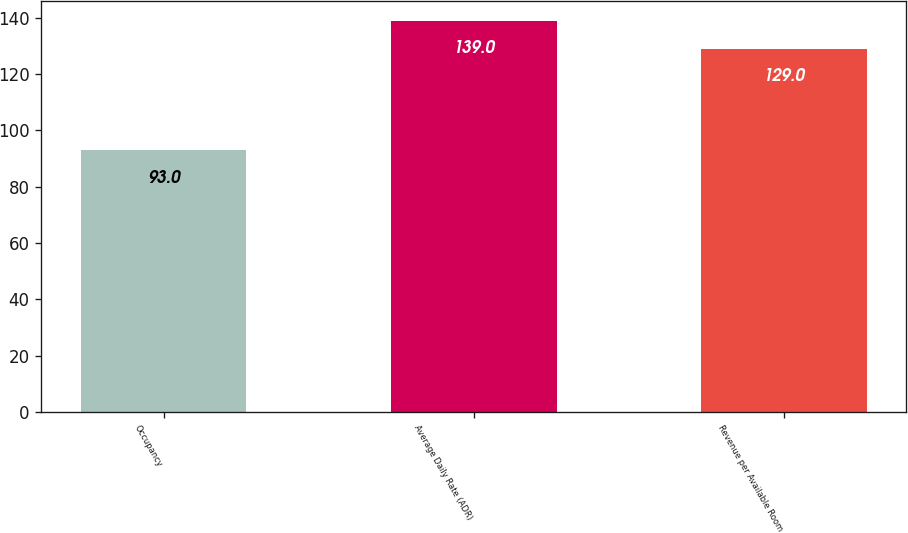Convert chart. <chart><loc_0><loc_0><loc_500><loc_500><bar_chart><fcel>Occupancy<fcel>Average Daily Rate (ADR)<fcel>Revenue per Available Room<nl><fcel>93<fcel>139<fcel>129<nl></chart> 